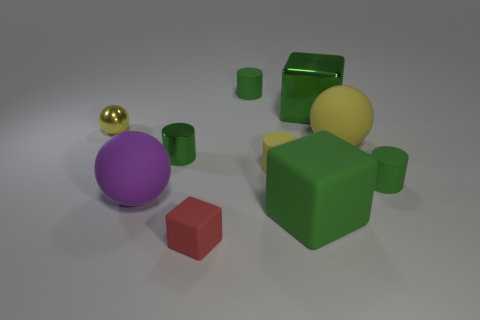Subtract all blue cubes. How many green cylinders are left? 3 Subtract all cubes. How many objects are left? 7 Add 1 big yellow objects. How many big yellow objects are left? 2 Add 2 small purple shiny blocks. How many small purple shiny blocks exist? 2 Subtract 0 gray cylinders. How many objects are left? 10 Subtract all tiny yellow rubber cylinders. Subtract all metallic cylinders. How many objects are left? 8 